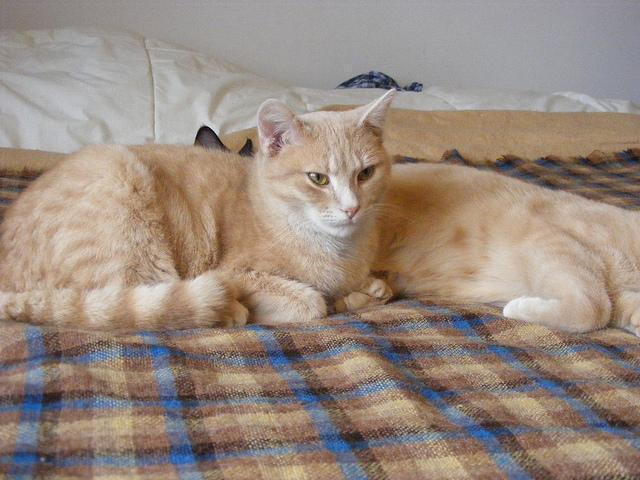How many cats are in the picture?
Give a very brief answer. 2. How many cats are on the bed?
Give a very brief answer. 2. How many cats are there?
Give a very brief answer. 2. How many cups are there?
Give a very brief answer. 0. 